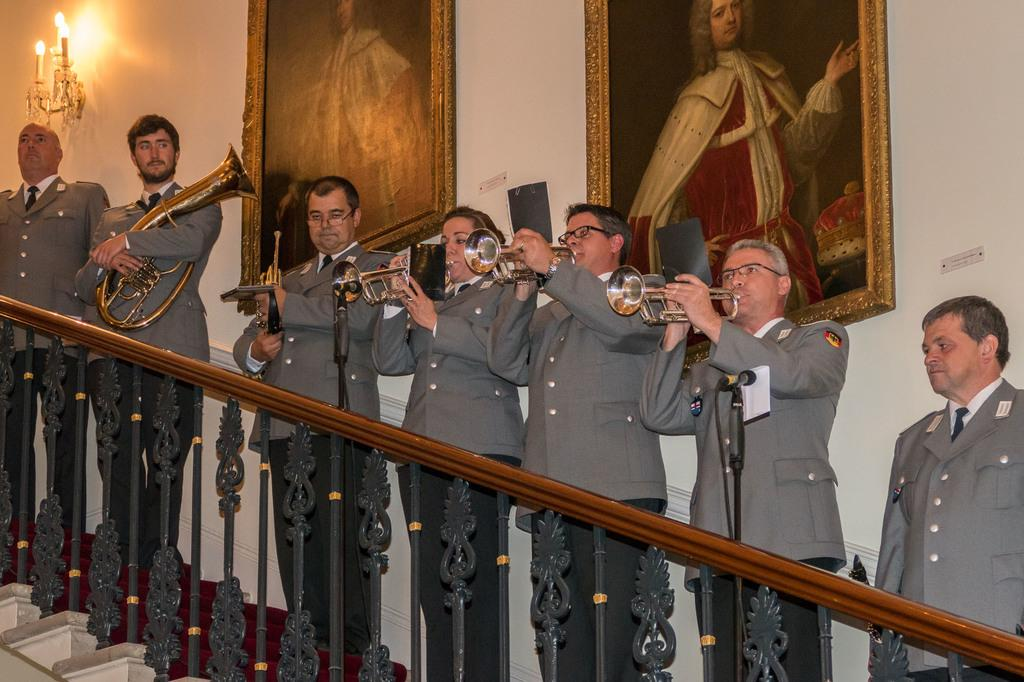What are the persons in the image doing? The persons in the image are playing musical instruments. What might be used to amplify their voices or instruments? There are microphones present in the image. Can you describe any architectural features in the image? Yes, there is a staircase visible in the image. What type of lighting is present in the image? There is a light in the image. What else can be seen in the image besides the persons and musical instruments? There are frames and a wall in the background. What type of lipstick is being used by the person on the right side of the image? There is no person on the right side of the image, nor is there any lipstick present in the image. 